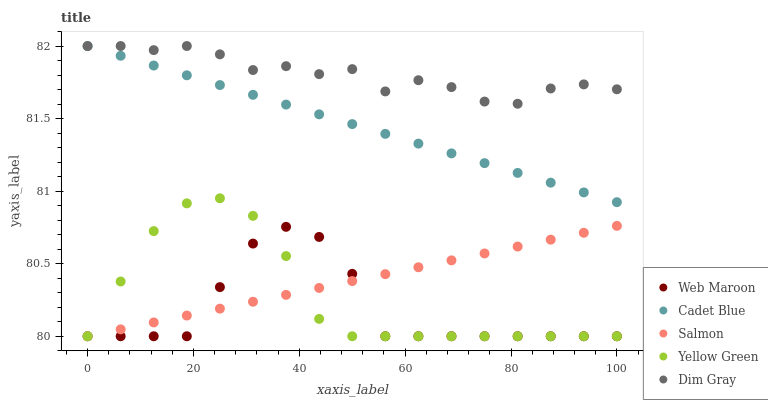Does Web Maroon have the minimum area under the curve?
Answer yes or no. Yes. Does Dim Gray have the maximum area under the curve?
Answer yes or no. Yes. Does Cadet Blue have the minimum area under the curve?
Answer yes or no. No. Does Cadet Blue have the maximum area under the curve?
Answer yes or no. No. Is Salmon the smoothest?
Answer yes or no. Yes. Is Web Maroon the roughest?
Answer yes or no. Yes. Is Dim Gray the smoothest?
Answer yes or no. No. Is Dim Gray the roughest?
Answer yes or no. No. Does Salmon have the lowest value?
Answer yes or no. Yes. Does Cadet Blue have the lowest value?
Answer yes or no. No. Does Cadet Blue have the highest value?
Answer yes or no. Yes. Does Web Maroon have the highest value?
Answer yes or no. No. Is Web Maroon less than Dim Gray?
Answer yes or no. Yes. Is Cadet Blue greater than Web Maroon?
Answer yes or no. Yes. Does Web Maroon intersect Yellow Green?
Answer yes or no. Yes. Is Web Maroon less than Yellow Green?
Answer yes or no. No. Is Web Maroon greater than Yellow Green?
Answer yes or no. No. Does Web Maroon intersect Dim Gray?
Answer yes or no. No. 